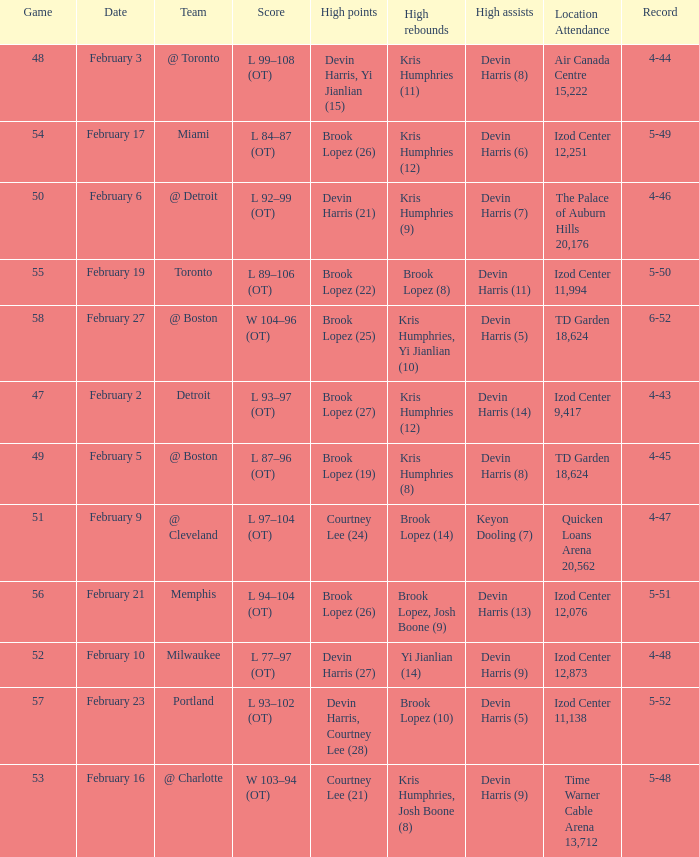What's the highest game number for a game in which Kris Humphries (8) did the high rebounds? 49.0. 